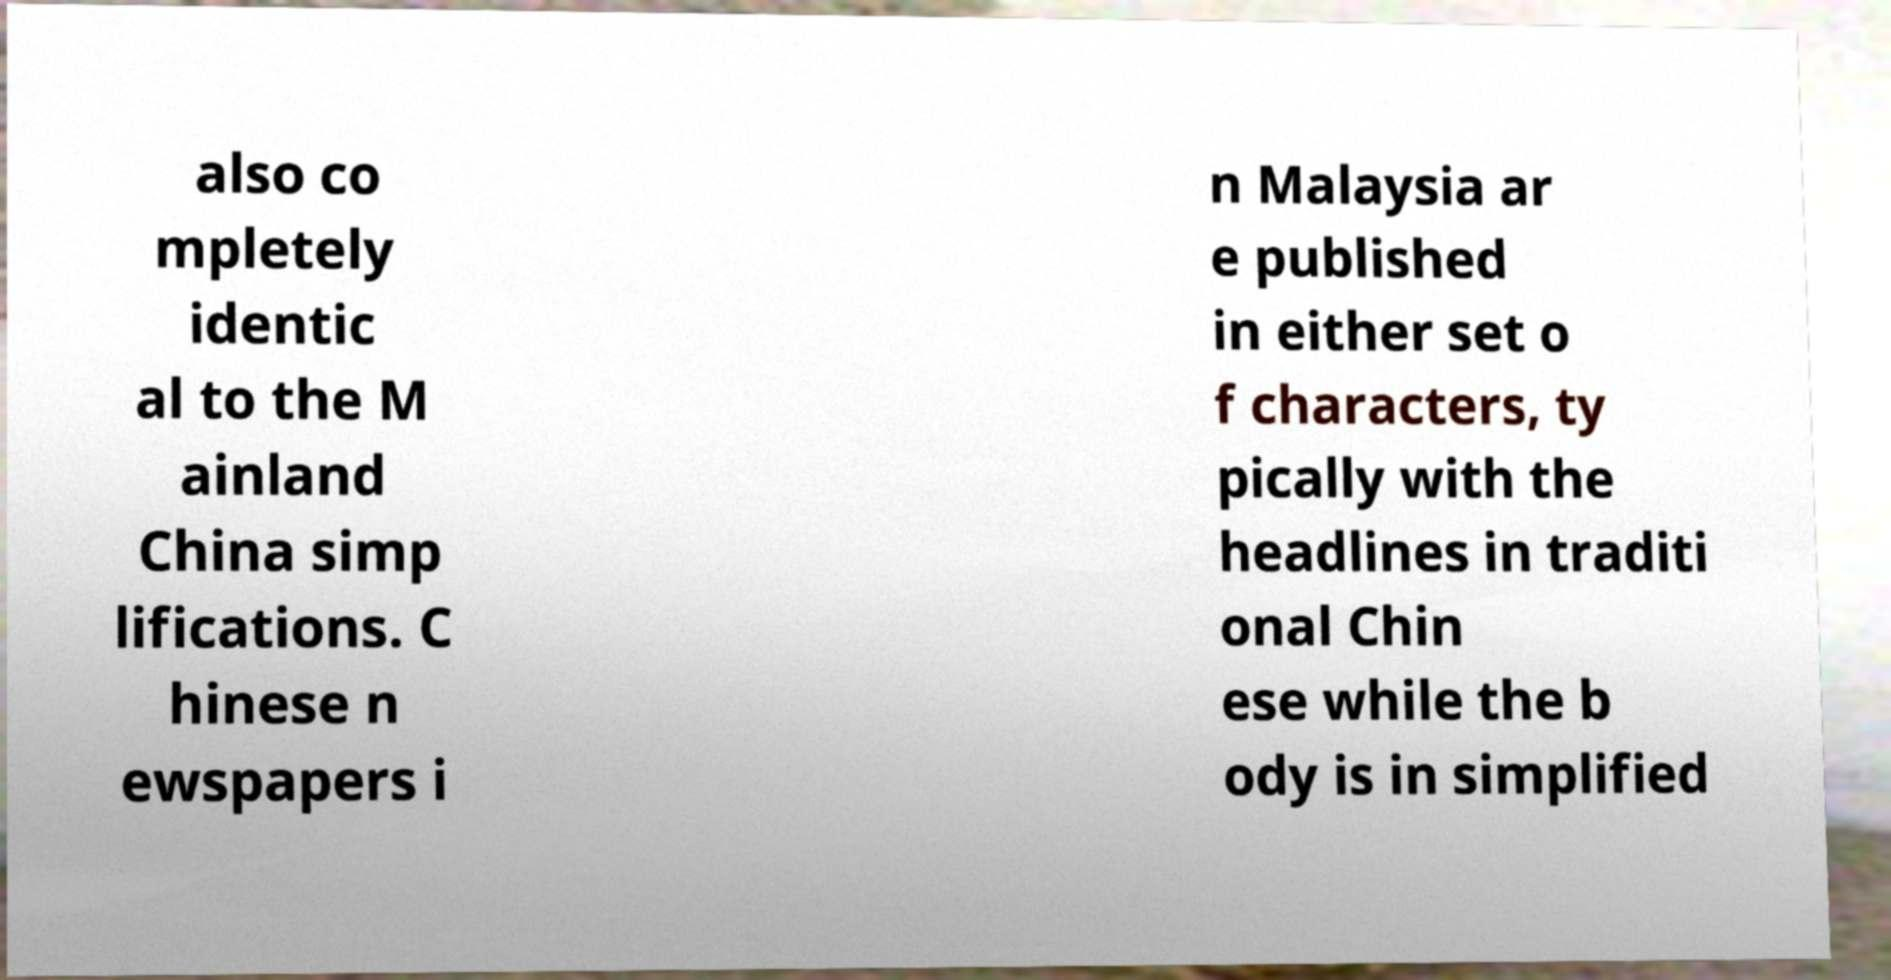Could you extract and type out the text from this image? also co mpletely identic al to the M ainland China simp lifications. C hinese n ewspapers i n Malaysia ar e published in either set o f characters, ty pically with the headlines in traditi onal Chin ese while the b ody is in simplified 